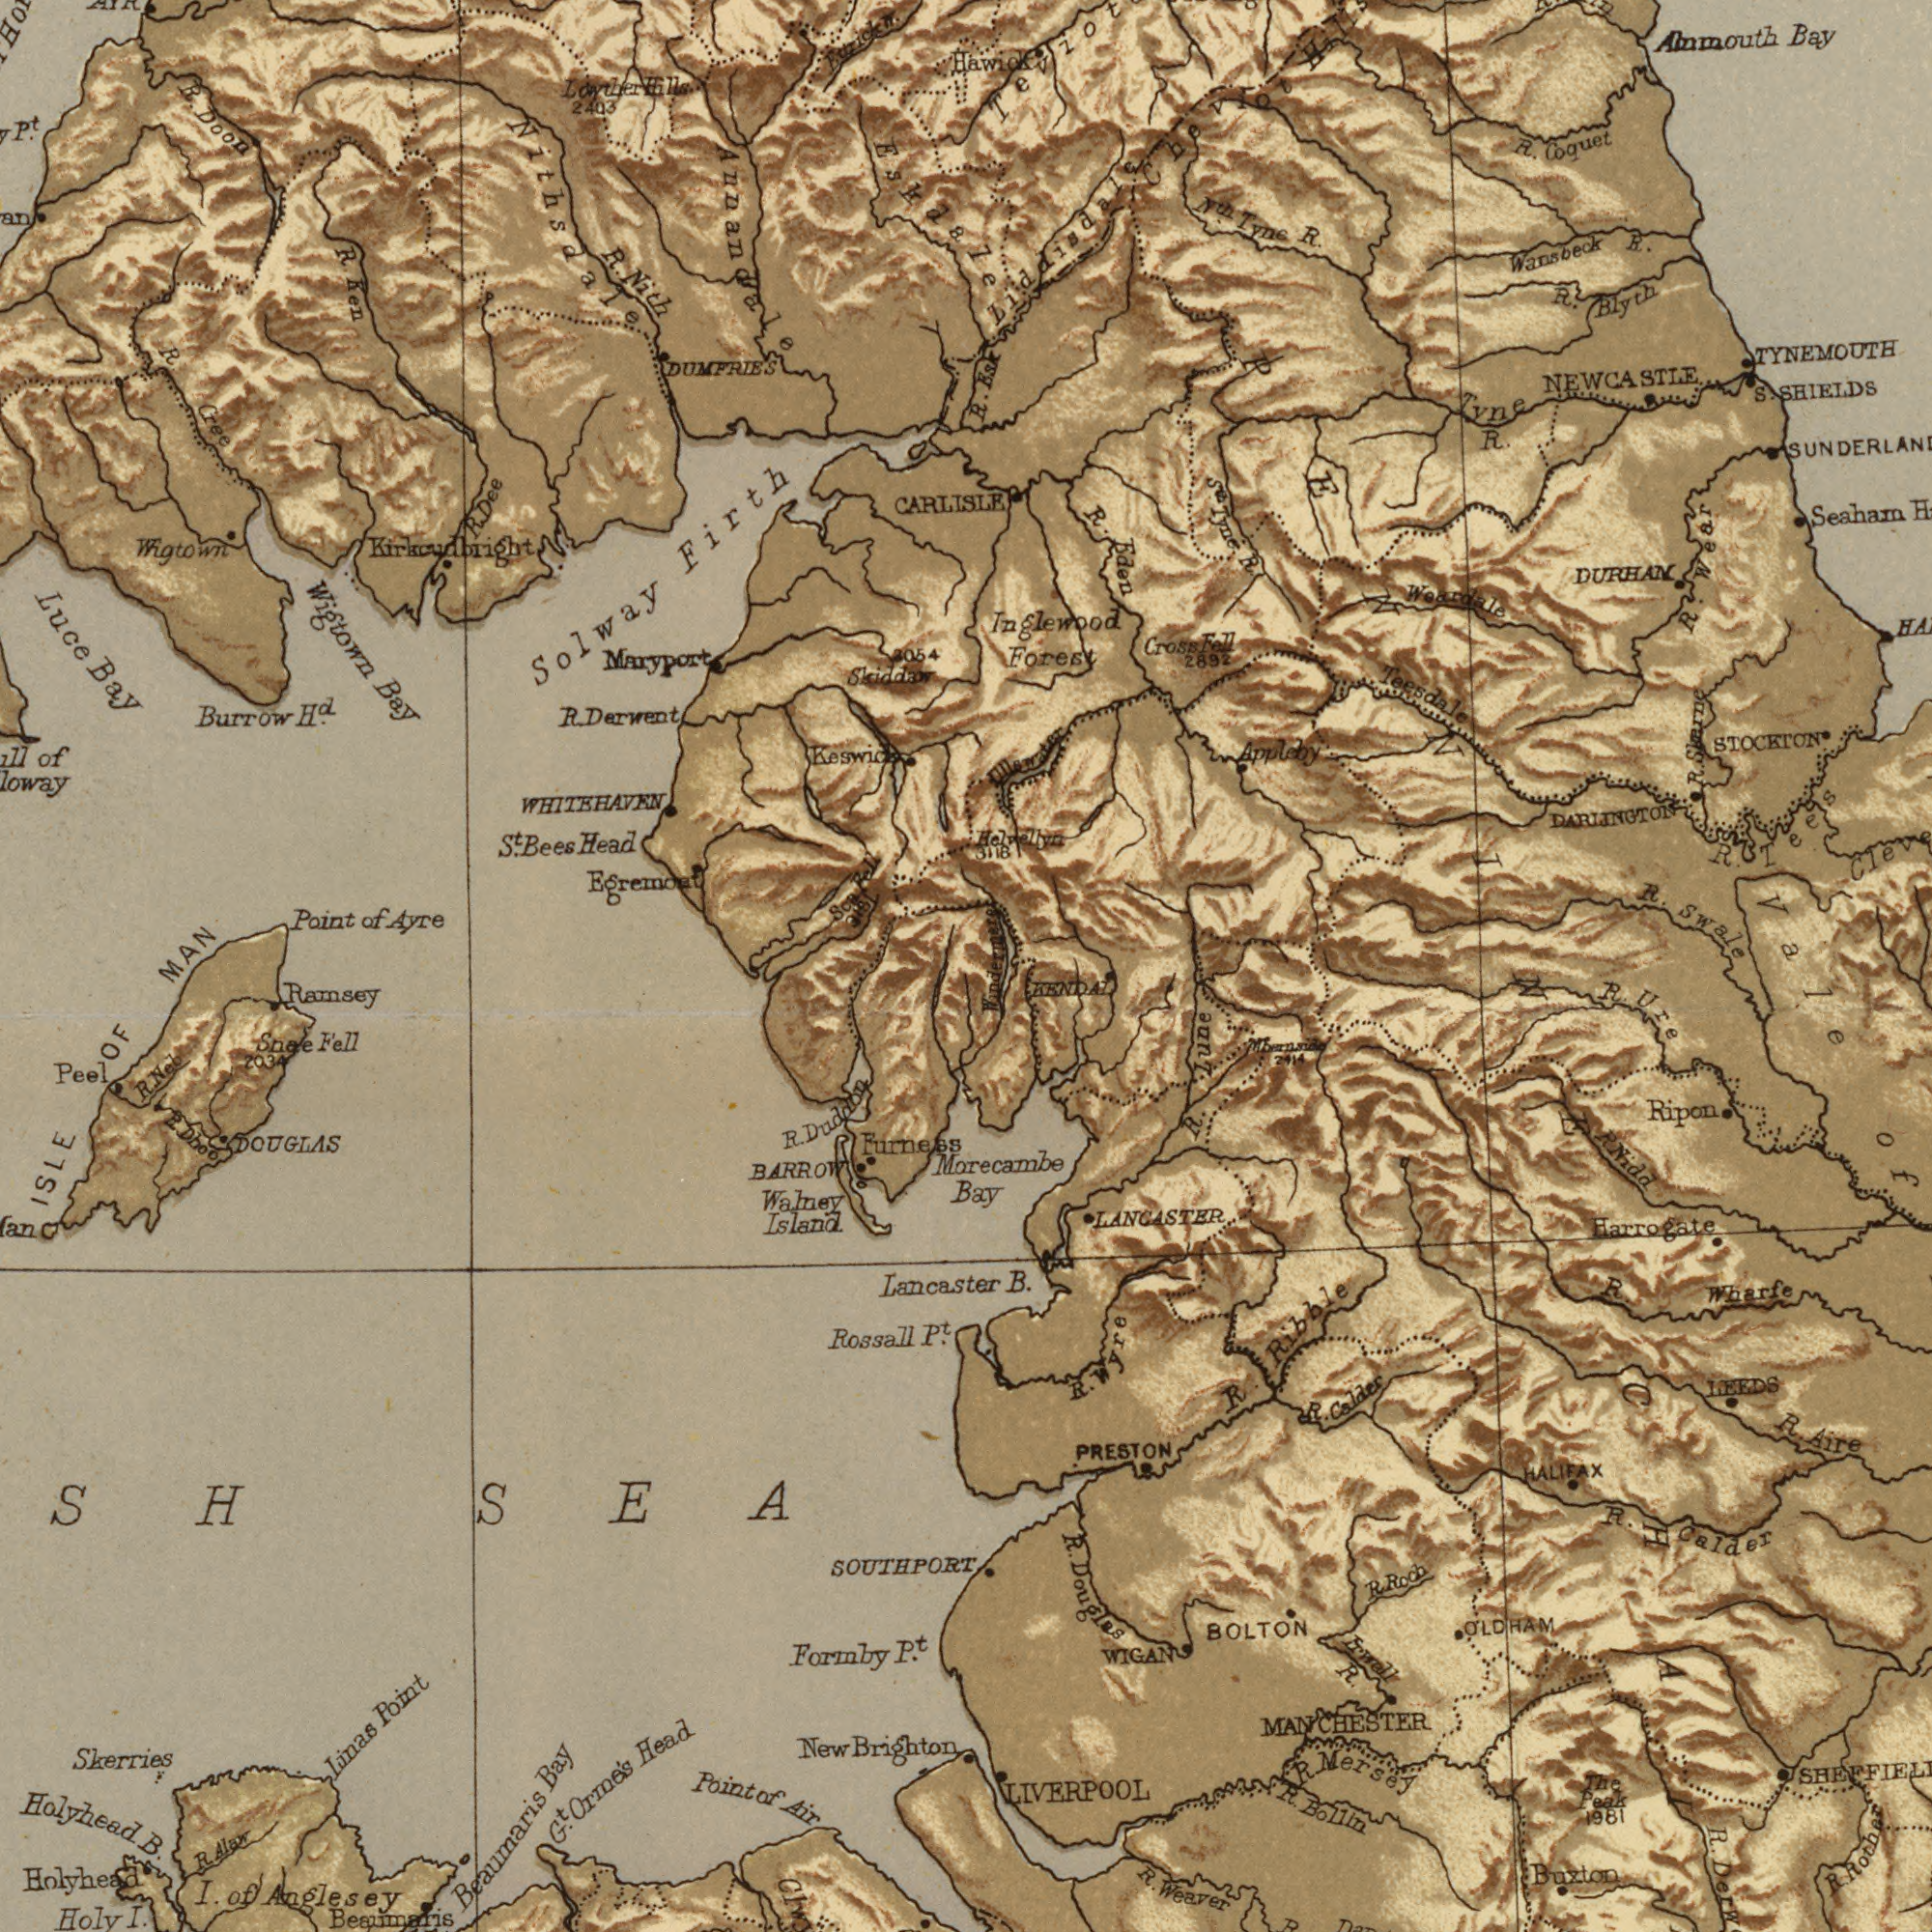What text appears in the bottom-left area of the image? Holyhead Beaumaris Island Peel ISLE Head Bay Brighton Formby Anglesey I. Point Point Rossall P<sup>t</sup>. Ramsey New Air Walney SEA P<sup>t</sup>. Holyhead Fell OF Lancaster Orme's Linas I. Holy Furness Beaumaris B. BARROW Neb Dboo of Duddon DOUGLAS G<sup>t</sup>. Snae R. R. R. Skerries Alaw SOUTHPORT 2034 R. of What text can you see in the top-right section? Bay Seaham Swale DURHAN R. TYNEMOUTH Forest Wansbeck R. R. R. Eden Coquet Tyne STOCKTON R. DARLINGTON Alnmouth Blyth Teesdale R. R. R. NEWCASTLE Appleby R. Cross R. Liddisdale SHIELDS Tyne S. 2892 Woardale Fell Tyne N<sup>tn</sup>. Tees Helvellyn 3118 R. Inglewood Vale Hawick Wear Chevlot R. Skerne ###ter Esk What text appears in the top-left area of the image? Solway Wigtown WHITEHAVEN Luce Nithsdale Wigtown Point Firth Bay Burrow CARLISLE Nith Eskdale Head Annandale R. Doon Kirkcudbright R. Ayre Egremont Dee MAN H<sup>d</sup>. Cree Ken Maryport Bees P<sup>t</sup>. Derwent R. Bay of of Skiddaw S<sup>t</sup>. Hills Loyther DUMFRIES R. 2054 R. 2403 318 Rell R. What text is visible in the lower-right corner? LIVERPOOL B. Douglas R. R. Wharfe R. Weaver Ribble Morecambe Calder BOLTON Roch Mersey Aire Ripon R. OLDHAM R. Bollin PRESTON Frwell R. Harrogate R. Buzton Lune R. WIGAN Nidd LEEDS Calder R. 1981 R. MANCHESTER Ure LANGASTER R. of R. Bay Rother R. KENDAL The Peak HALIFAX R. R. 2414 Wyre PENNINECHA R. R. 